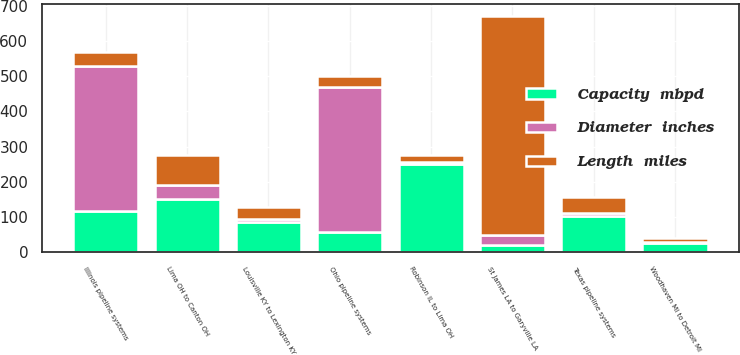Convert chart. <chart><loc_0><loc_0><loc_500><loc_500><stacked_bar_chart><ecel><fcel>Lima OH to Canton OH<fcel>St James LA to Garyville LA<fcel>Robinson IL to Lima OH<fcel>Louisville KY to Lexington KY<fcel>Woodhaven MI to Detroit MI<fcel>Illinois pipeline systems<fcel>Texas pipeline systems<fcel>Ohio pipeline systems<nl><fcel>Diameter  inches<fcel>39<fcel>30<fcel>8<fcel>8<fcel>4<fcel>412<fcel>8<fcel>412<nl><fcel>Capacity  mbpd<fcel>153<fcel>20<fcel>250<fcel>87<fcel>26<fcel>118<fcel>103<fcel>57<nl><fcel>Length  miles<fcel>84<fcel>620<fcel>18<fcel>34<fcel>11<fcel>39<fcel>45<fcel>32<nl></chart> 